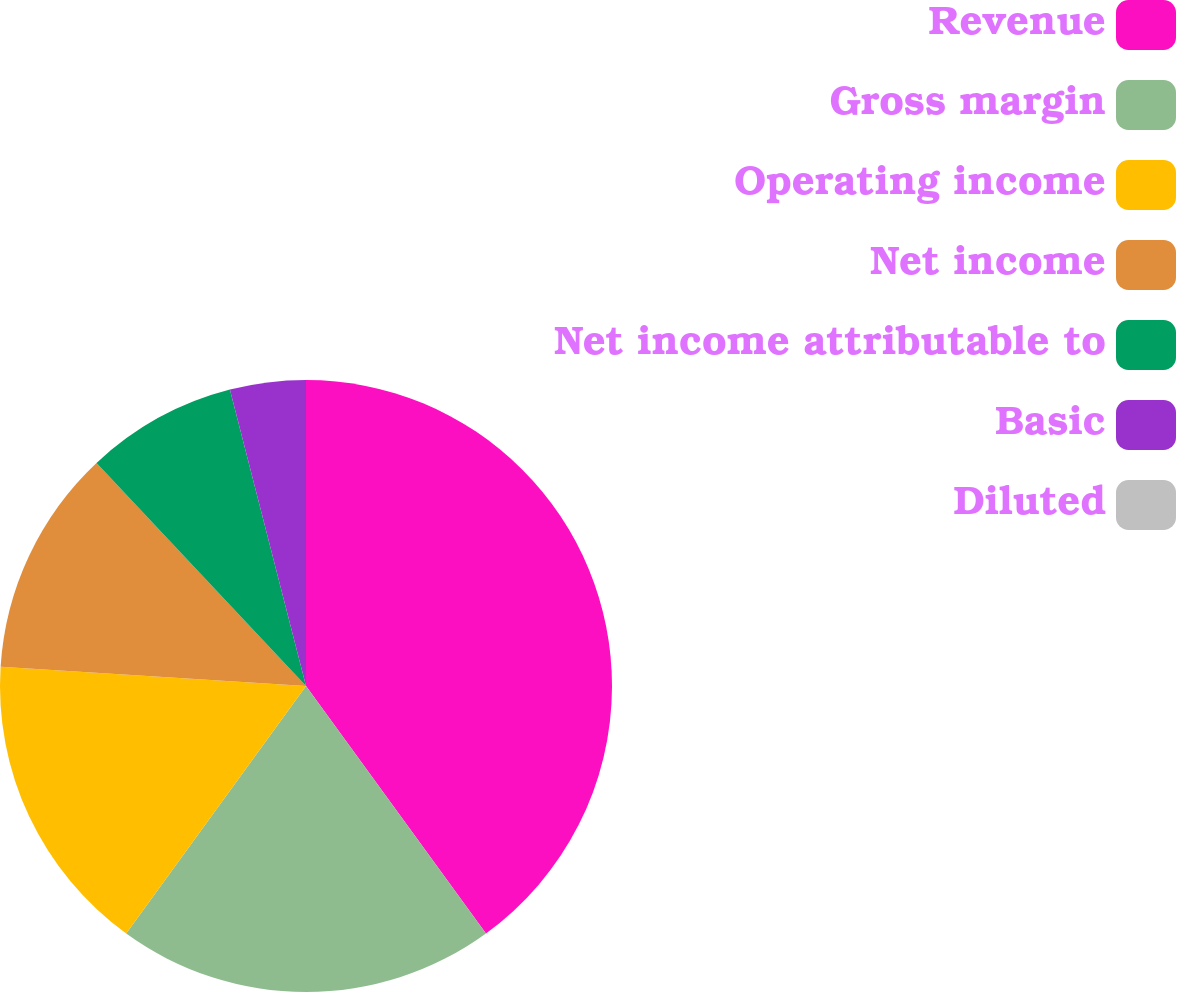Convert chart to OTSL. <chart><loc_0><loc_0><loc_500><loc_500><pie_chart><fcel>Revenue<fcel>Gross margin<fcel>Operating income<fcel>Net income<fcel>Net income attributable to<fcel>Basic<fcel>Diluted<nl><fcel>39.99%<fcel>20.0%<fcel>16.0%<fcel>12.0%<fcel>8.0%<fcel>4.0%<fcel>0.0%<nl></chart> 